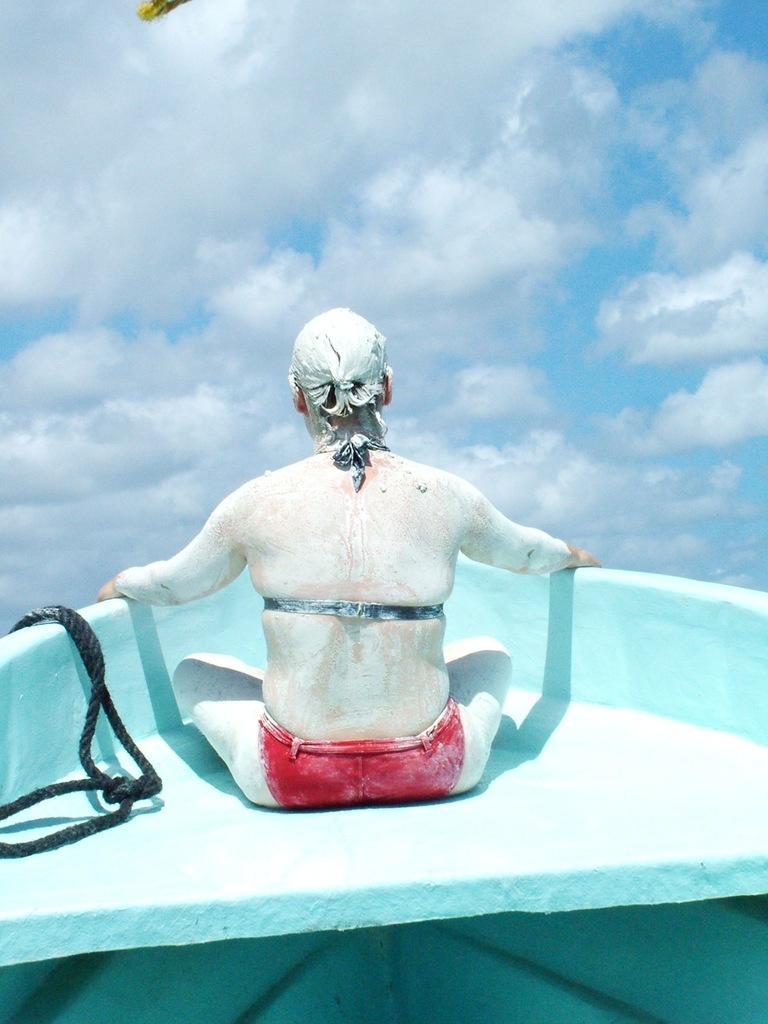Can you describe this image briefly? In this image there is a person is sitting on a boat having a rope. This person has painted his body. Top of image there is sky with some clouds. 